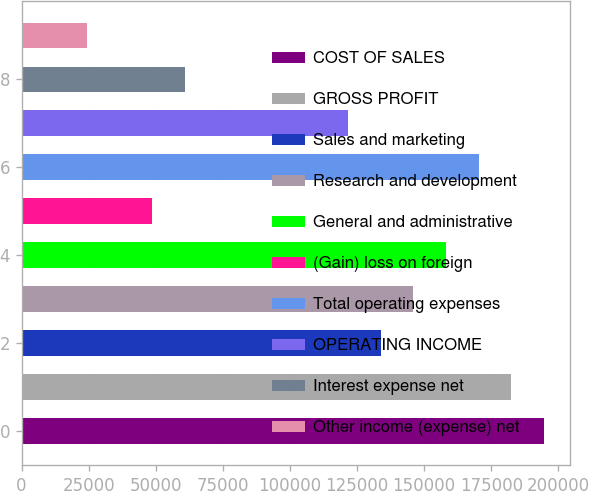<chart> <loc_0><loc_0><loc_500><loc_500><bar_chart><fcel>COST OF SALES<fcel>GROSS PROFIT<fcel>Sales and marketing<fcel>Research and development<fcel>General and administrative<fcel>(Gain) loss on foreign<fcel>Total operating expenses<fcel>OPERATING INCOME<fcel>Interest expense net<fcel>Other income (expense) net<nl><fcel>194602<fcel>182439<fcel>133789<fcel>145951<fcel>158114<fcel>48650.5<fcel>170276<fcel>121626<fcel>60813.1<fcel>24325.3<nl></chart> 